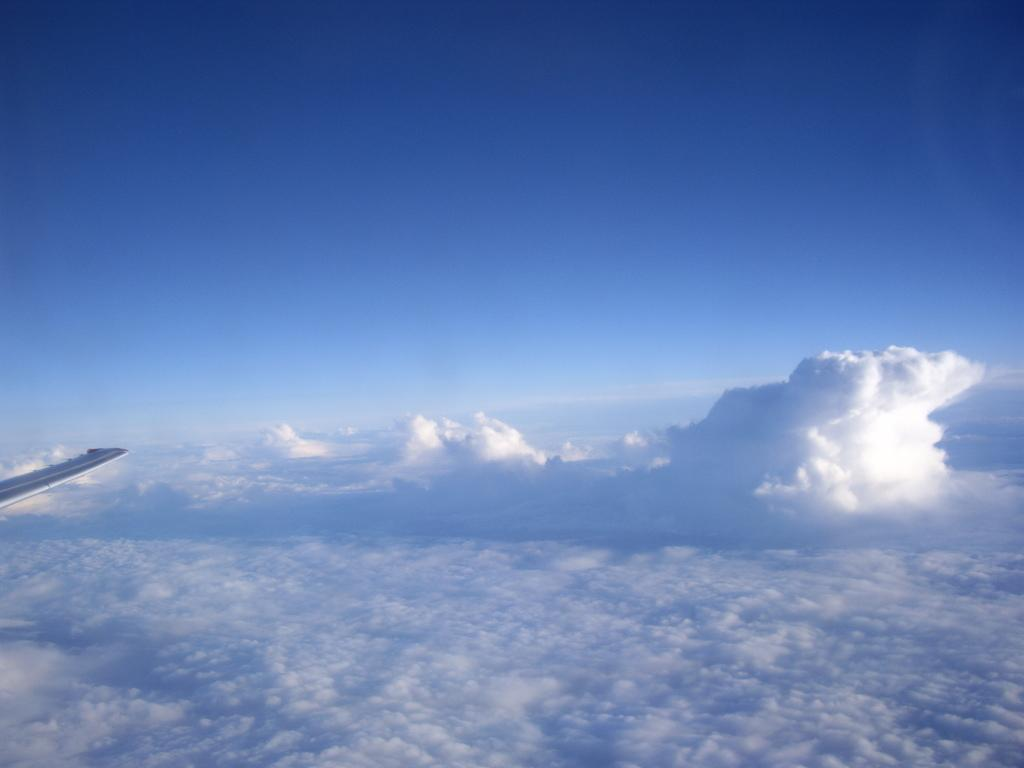What is located on the left side of the image? There is an airplane wing on the left side of the image. What can be seen at the bottom of the image? Clouds are visible at the bottom of the image. What is visible at the top of the image? The sky is visible at the top of the image. Can you tell me how many bats are flying in the image? There are no bats present in the image; it features an airplane wing and clouds. What type of riddle is being solved by the hen in the image? There is no hen or riddle present in the image. 